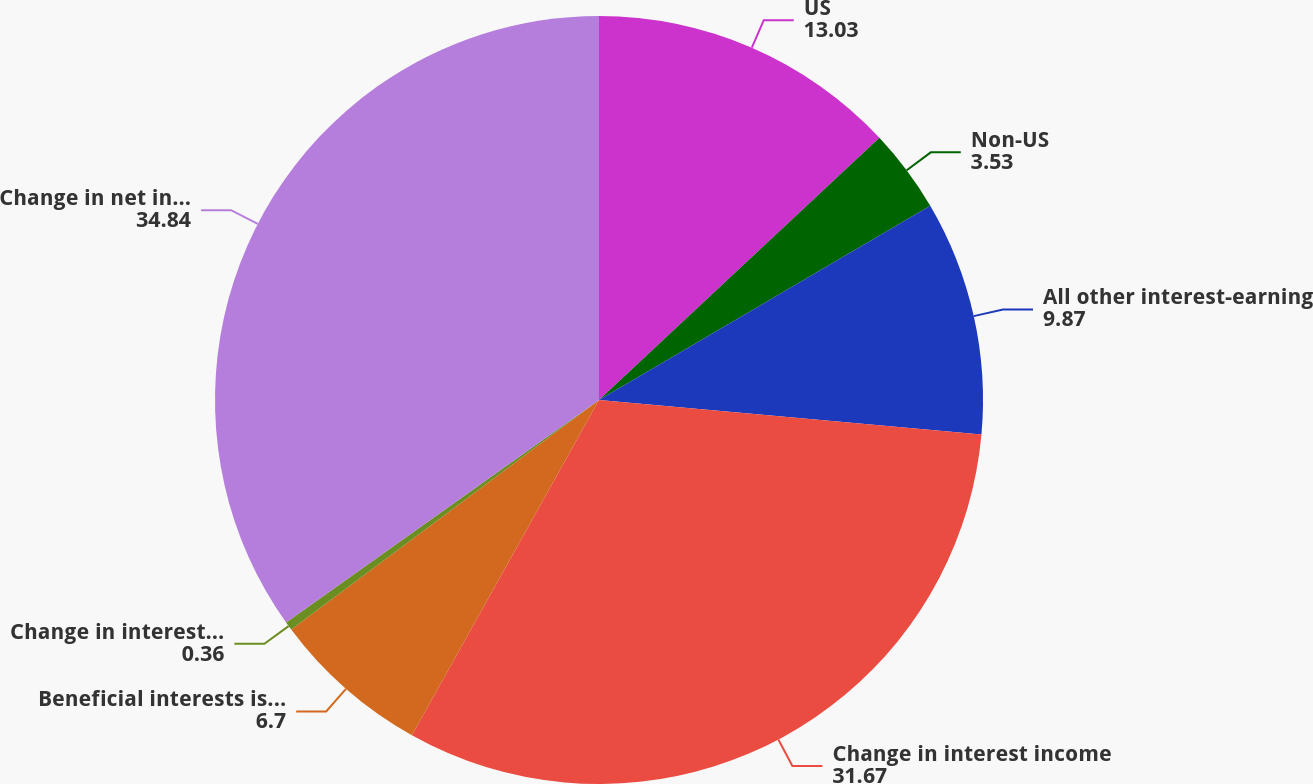Convert chart to OTSL. <chart><loc_0><loc_0><loc_500><loc_500><pie_chart><fcel>US<fcel>Non-US<fcel>All other interest-earning<fcel>Change in interest income<fcel>Beneficial interests issued by<fcel>Change in interest expense<fcel>Change in net interest income<nl><fcel>13.03%<fcel>3.53%<fcel>9.87%<fcel>31.67%<fcel>6.7%<fcel>0.36%<fcel>34.84%<nl></chart> 